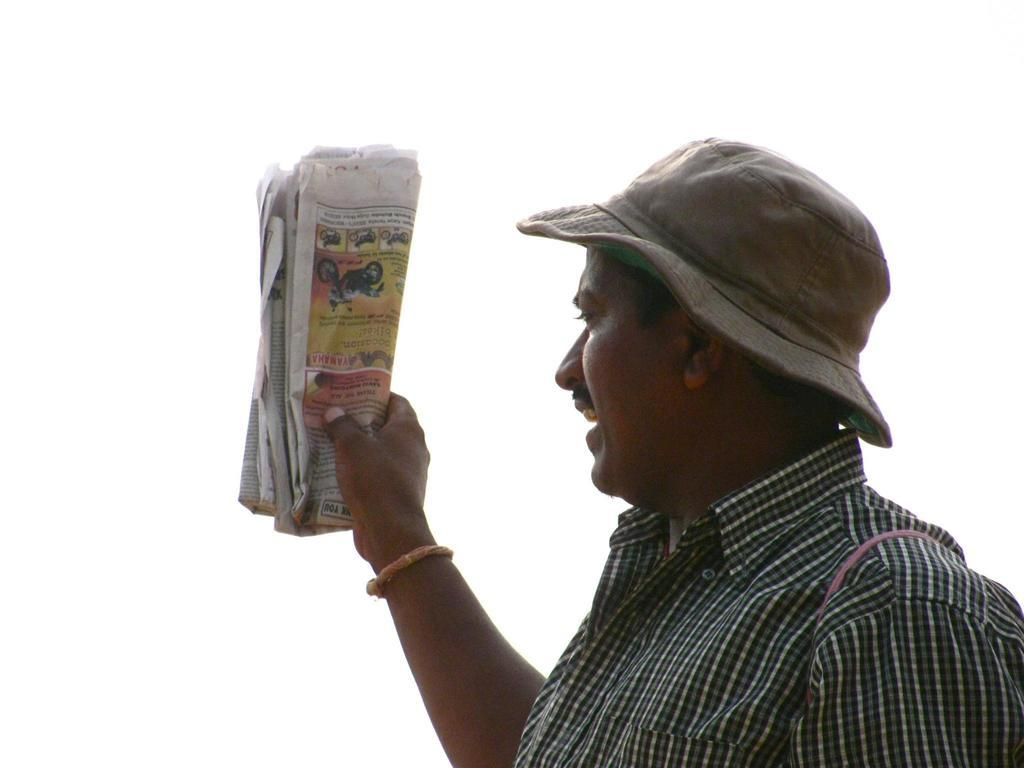Who is the main subject in the image? There is a man in the picture. What is the man doing in the image? The man is standing. What is the man holding in his hand? The man is holding a newspaper in his hand. What accessory is the man wearing in the image? The man is wearing a hat. What type of bubble can be seen floating near the man in the image? There is no bubble present in the image. Is the man standing near a dock in the image? There is no dock present in the image. 